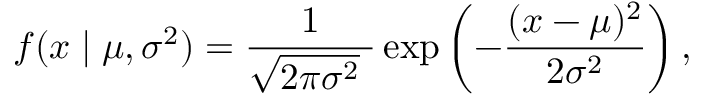Convert formula to latex. <formula><loc_0><loc_0><loc_500><loc_500>f ( x | \mu , \sigma ^ { 2 } ) = { \frac { 1 } { { \sqrt { 2 \pi \sigma ^ { 2 } } } \ } } \exp \left ( - { \frac { ( x - \mu ) ^ { 2 } } { 2 \sigma ^ { 2 } } } \right ) ,</formula> 